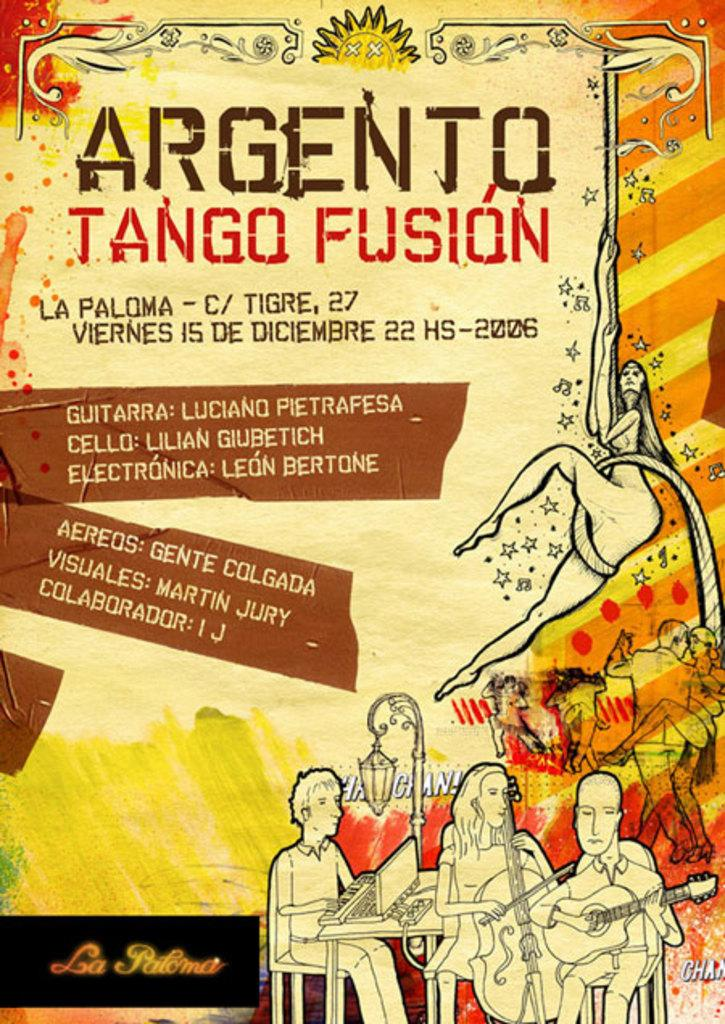<image>
Relay a brief, clear account of the picture shown. poster that is yellow, orange, and red with argento tango fusion written at top 